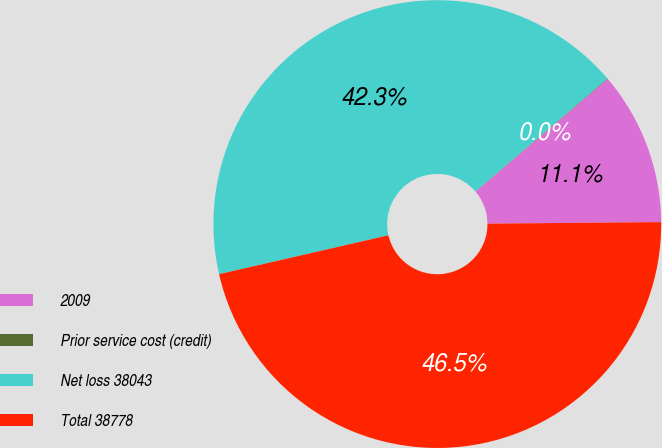Convert chart. <chart><loc_0><loc_0><loc_500><loc_500><pie_chart><fcel>2009<fcel>Prior service cost (credit)<fcel>Net loss 38043<fcel>Total 38778<nl><fcel>11.09%<fcel>0.04%<fcel>42.32%<fcel>46.55%<nl></chart> 